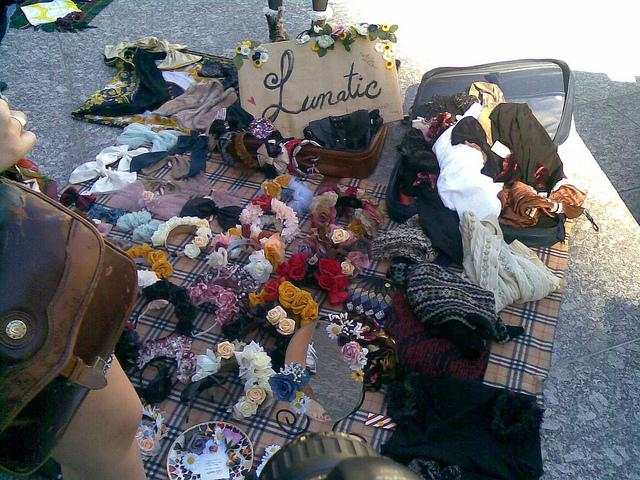Which type flower is most oft repeated here? Please explain your reasoning. rose. Roses are scattered throughout. 